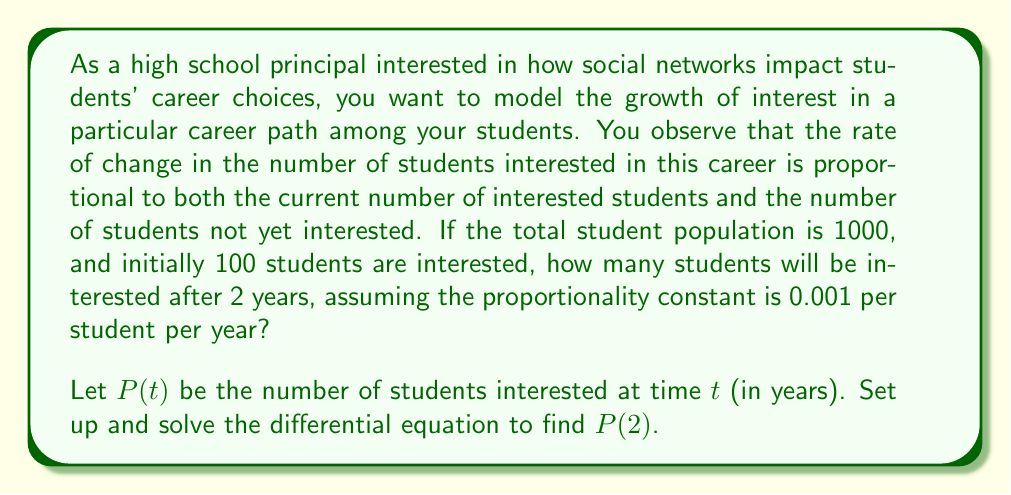Can you answer this question? To solve this problem, we'll follow these steps:

1) Set up the differential equation:
   The rate of change is proportional to $P(t)$ and $(1000 - P(t))$:
   
   $$\frac{dP}{dt} = kP(1000 - P)$$

   where $k = 0.001$ is the proportionality constant.

2) This is a logistic differential equation. Its solution is:

   $$P(t) = \frac{1000}{1 + Ce^{-1000kt}}$$

   where $C$ is a constant we need to determine from the initial condition.

3) Use the initial condition $P(0) = 100$ to find $C$:

   $$100 = \frac{1000}{1 + C}$$
   
   $$C = 9$$

4) Now our specific solution is:

   $$P(t) = \frac{1000}{1 + 9e^{-t}}$$

5) To find $P(2)$, we substitute $t = 2$:

   $$P(2) = \frac{1000}{1 + 9e^{-2}}$$

6) Calculate the result:
   
   $$P(2) = \frac{1000}{1 + 9e^{-2}} \approx 231.06$$

Therefore, after 2 years, approximately 231 students will be interested in this career path.
Answer: Approximately 231 students 